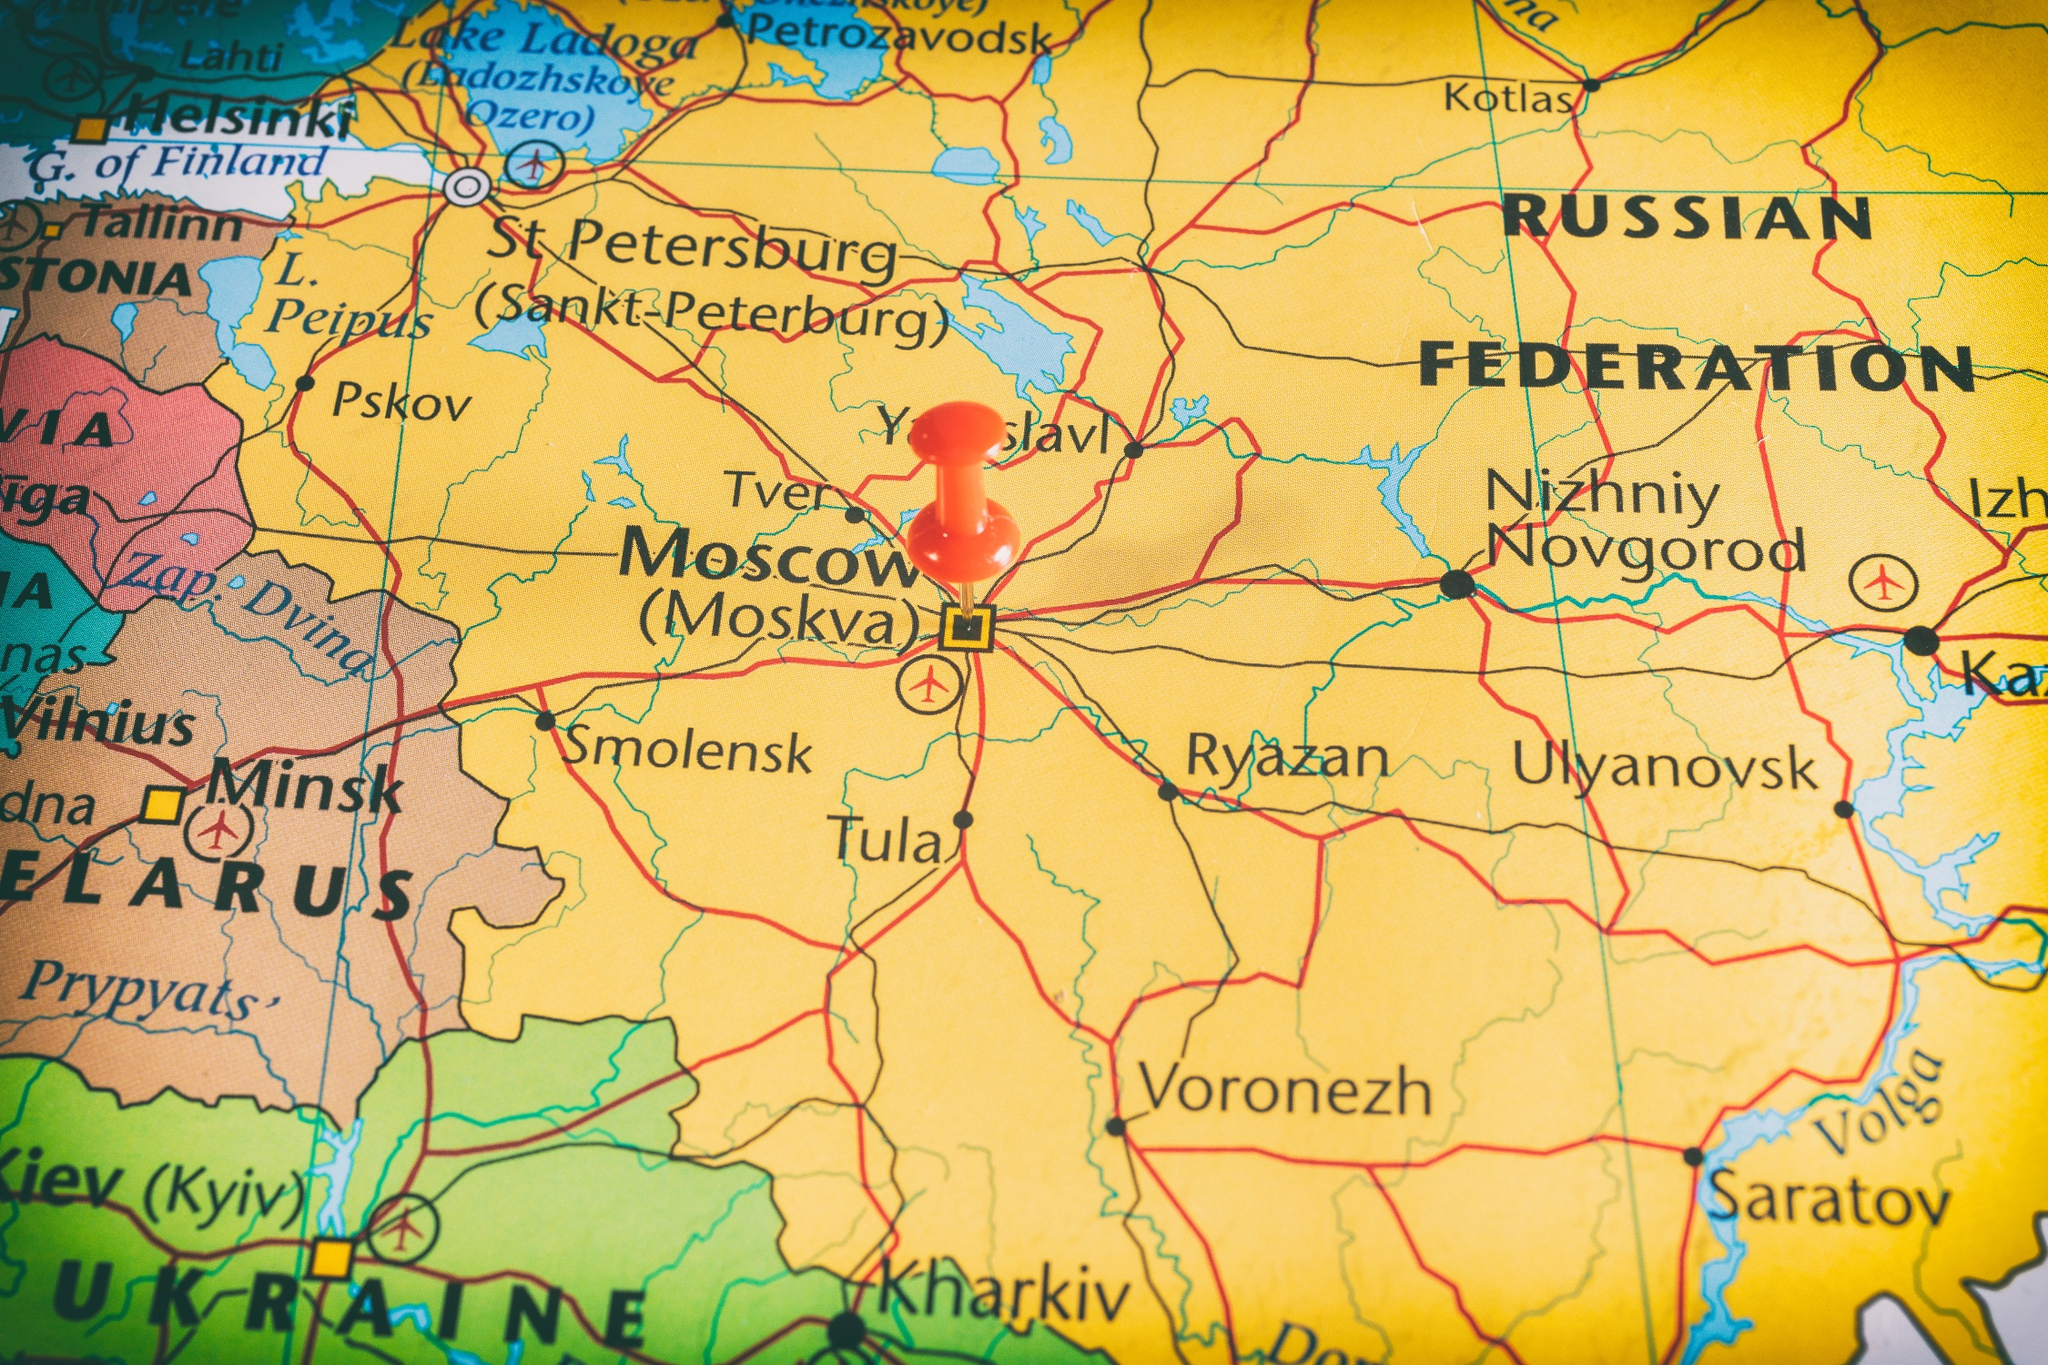Can you describe the historical significance of the highlighted regions on this map? The highlighted region on the map primarily showcases the western part of Russia, including its capital, Moscow. This area holds significant historical importance as the center of political power and cultural influence in Russia. Moscow, famously known as a major political, economic, and cultural center, is often considered the heart of Russia. Historically, it has been the focal point for numerous significant events, including the power struggles during the Tsardom of Russia, the Napoleonic Wars, and its critical role during the Soviet era. St. Petersburg, another major city visible on the map, served as the imperial capital for two centuries and is renowned for its architectural grandeur and cultural heritage. The roads and transportation networks depicted are crucial pathways that have supported trade, military movements, and communication across the vast expanses of Russia, linking the central regions with the peripheries. The intricate layout of cities and roads reveals how this region has developed over centuries, shaping the country's historical and cultural landscape. What might daily life look like for someone living in Moscow, according to this map? Based on this detailed map, daily life for someone living in Moscow, the capital of Russia, would be bustling and dynamic. Moscow is a major city with an extensive network of roads and transport routes radiating from it, indicating a well-connected metropolis. Residents would likely experience a busy urban lifestyle with access to numerous amenities, including government institutions, educational establishments, historical sites, and cultural venues like theaters and museums. The presence of several major cities nearby, such as Ryazan, Tula, and Nizhniy Novgorod, connected by significant roads, suggests that there is regular movement of goods and people to and from Moscow, contributing to its economic vitality. The strategic placing of the red pin on Moscow underlines its significance as the central hub of the country, which means that many residents might be engaged in activities related to governance, business, and international relations. Life here would be characterized by a blend of modern living with rich historical and cultural experiences. 